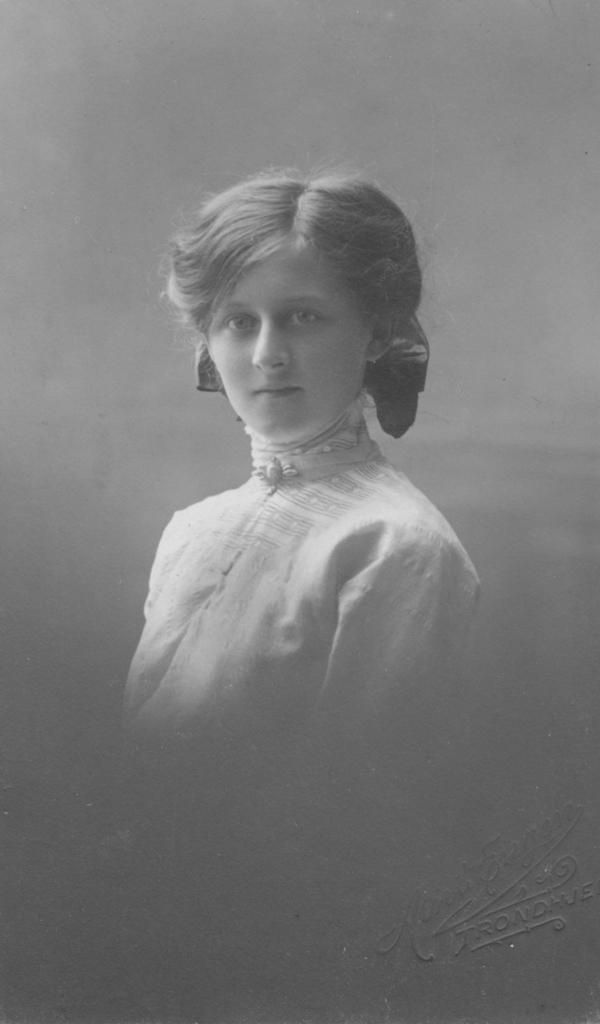Who is the main subject in the image? There is a girl in the image. What is the color of the background in the image? The background of the image is grey. Is there any text present in the image? Yes, there is some text in the bottom right corner of the image. What type of rhythm can be heard coming from the girl in the image? There is no indication of sound or rhythm in the image, as it is a still photograph of a girl. Does the girl have any wings in the image? No, the girl does not have any wings in the image. What type of feast is being prepared in the image? There is no indication of a feast or any food preparation in the image. 